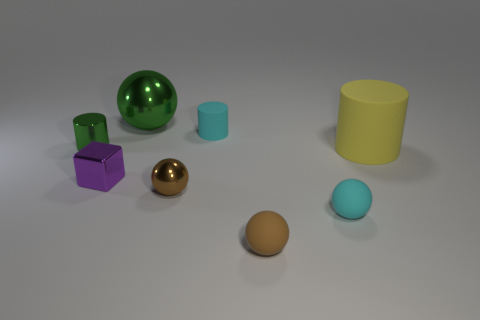Add 2 large yellow rubber cylinders. How many objects exist? 10 Subtract all blocks. How many objects are left? 7 Add 2 tiny blue metal things. How many tiny blue metal things exist? 2 Subtract 0 red balls. How many objects are left? 8 Subtract all cyan objects. Subtract all tiny cylinders. How many objects are left? 4 Add 2 tiny rubber spheres. How many tiny rubber spheres are left? 4 